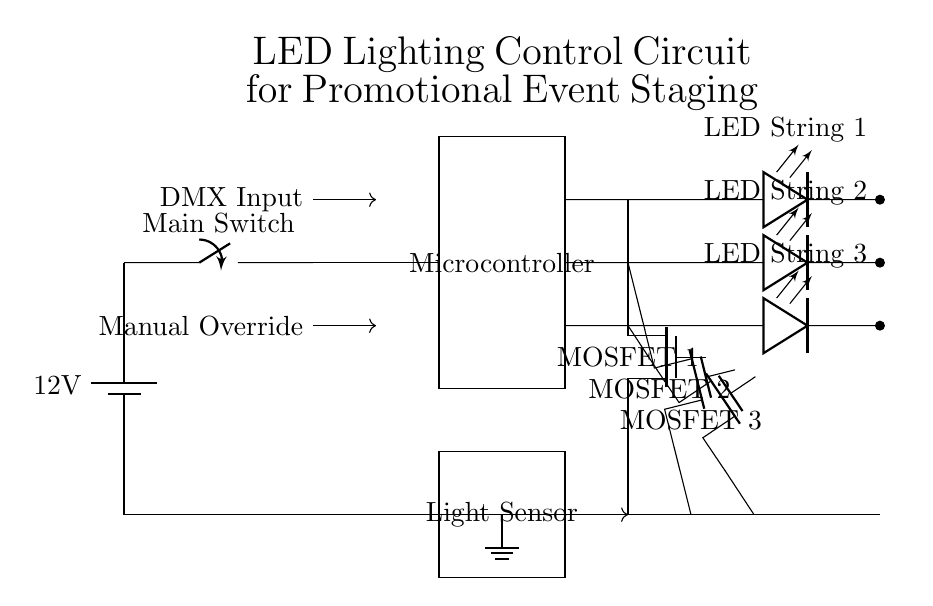What is the main voltage supply for the circuit? The main voltage supply for the circuit is twelve volts, indicated as the battery labeled 12 V at the start of the circuit diagram.
Answer: twelve volts How many LED strings are present in the circuit? There are three LED strings present, labeled LED String 1, LED String 2, and LED String 3, each depicted at different heights in the diagram.
Answer: three What type of inputs control the microcontroller? The microcontroller is controlled by DMX Input and Manual Override inputs, as shown by the arrows pointing into it in the diagram.
Answer: DMX Input and Manual Override What type of components are used to drive the LED strings? The LED strings are driven by MOSFET components, which are indicated as three separate MOSFET labeled in the diagram.
Answer: MOSFET Which component measures ambient light in the circuit? The light sensor is used to measure ambient light in the circuit, represented by a rectangle labeled Light Sensor in the diagram.
Answer: Light Sensor What is the role of the main switch in this circuit? The main switch connects the power supply to the rest of the circuit, allowing for the control of the circuitry by opening or closing the connection, as shown just after the battery.
Answer: to control power supply How do the MOSFET drivers interact with the LED strings? The MOSFET drivers control the current through the LED strings, allowing them to be turned on or off based on the control signals received from the microcontroller, showing their direct connection with the LED strings.
Answer: to control current flow 